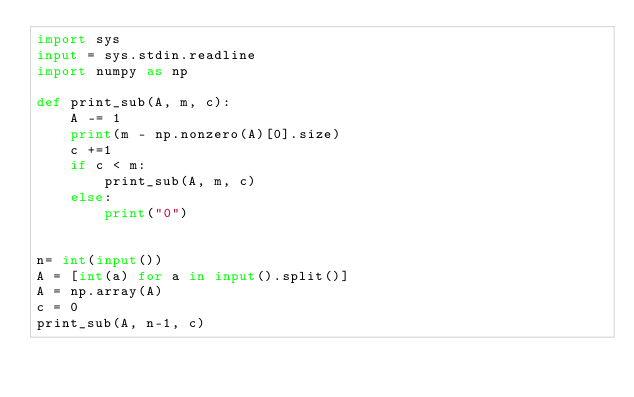<code> <loc_0><loc_0><loc_500><loc_500><_Python_>import sys
input = sys.stdin.readline
import numpy as np

def print_sub(A, m, c):
    A -= 1
    print(m - np.nonzero(A)[0].size)
    c +=1
    if c < m:
        print_sub(A, m, c)
    else:
        print("0")
        

n= int(input())
A = [int(a) for a in input().split()]
A = np.array(A)
c = 0
print_sub(A, n-1, c)
</code> 